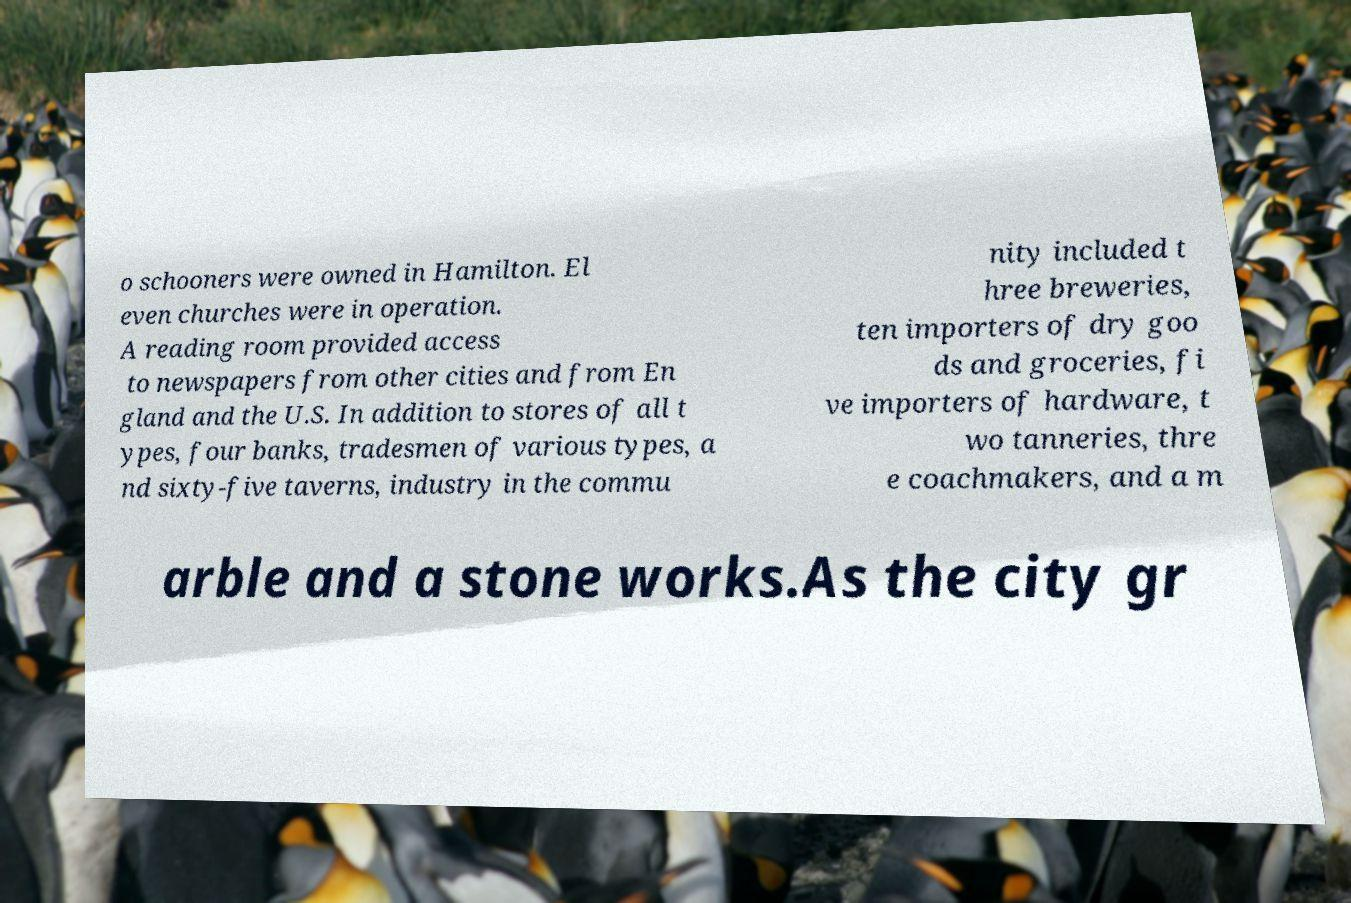There's text embedded in this image that I need extracted. Can you transcribe it verbatim? o schooners were owned in Hamilton. El even churches were in operation. A reading room provided access to newspapers from other cities and from En gland and the U.S. In addition to stores of all t ypes, four banks, tradesmen of various types, a nd sixty-five taverns, industry in the commu nity included t hree breweries, ten importers of dry goo ds and groceries, fi ve importers of hardware, t wo tanneries, thre e coachmakers, and a m arble and a stone works.As the city gr 